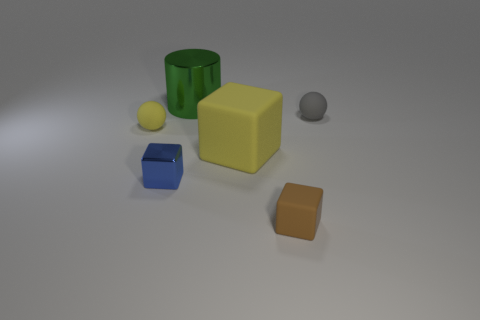Do the large cylinder and the metal cube have the same color?
Your response must be concise. No. What number of metallic objects are either large green objects or big yellow blocks?
Ensure brevity in your answer.  1. What number of small brown blocks are there?
Provide a short and direct response. 1. Are the small thing that is left of the metallic cube and the ball right of the cylinder made of the same material?
Your response must be concise. Yes. The tiny matte object that is the same shape as the large yellow object is what color?
Provide a short and direct response. Brown. There is a sphere that is behind the matte sphere that is to the left of the blue metallic cube; what is it made of?
Provide a succinct answer. Rubber. There is a yellow object that is to the right of the cylinder; does it have the same shape as the rubber object that is on the right side of the brown cube?
Your answer should be very brief. No. What is the size of the thing that is to the right of the large yellow matte cube and in front of the gray matte ball?
Keep it short and to the point. Small. What number of other things are there of the same color as the large block?
Give a very brief answer. 1. Is the material of the tiny ball on the left side of the gray matte ball the same as the big green thing?
Offer a terse response. No. 